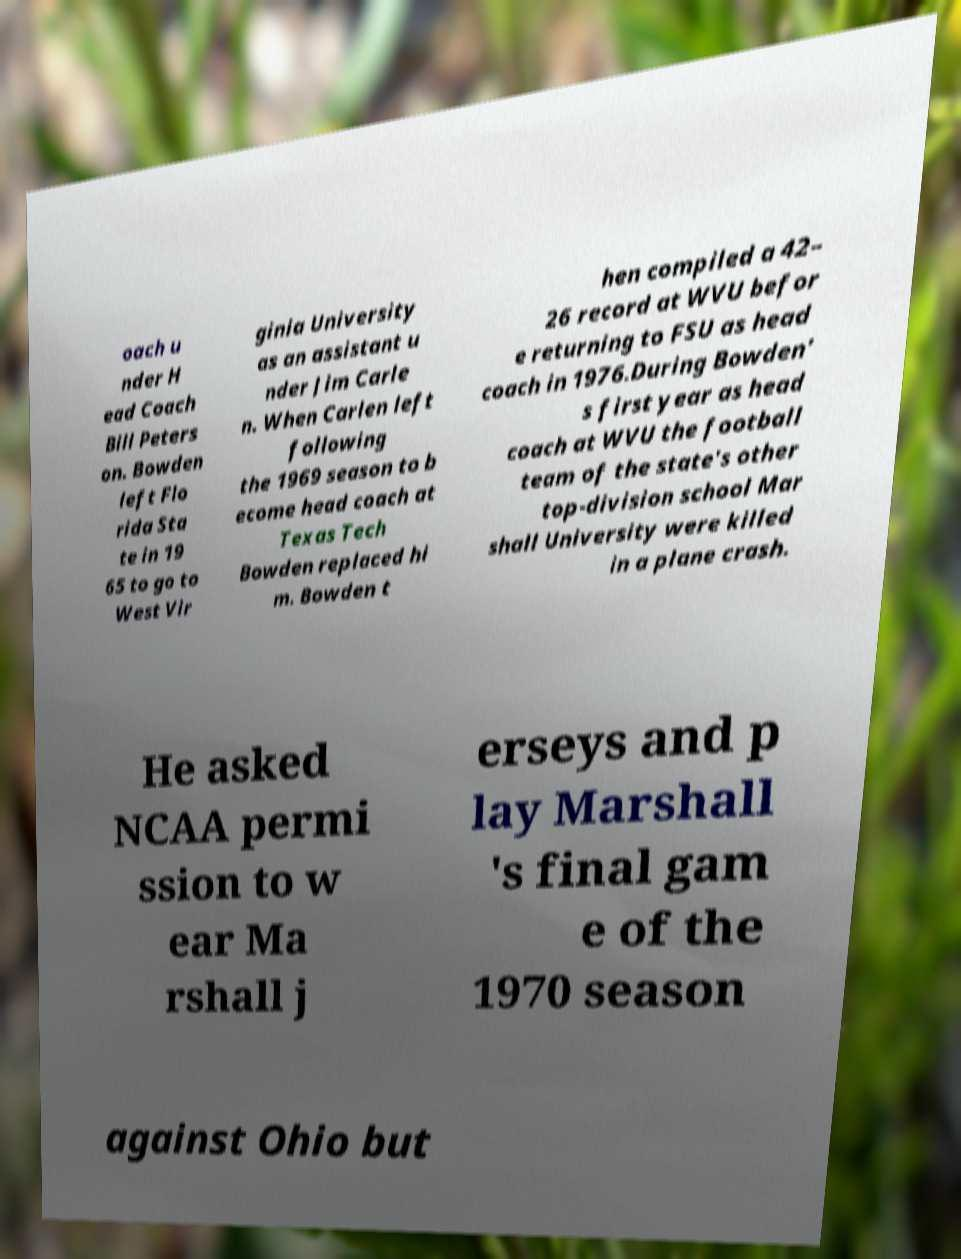Could you extract and type out the text from this image? oach u nder H ead Coach Bill Peters on. Bowden left Flo rida Sta te in 19 65 to go to West Vir ginia University as an assistant u nder Jim Carle n. When Carlen left following the 1969 season to b ecome head coach at Texas Tech Bowden replaced hi m. Bowden t hen compiled a 42– 26 record at WVU befor e returning to FSU as head coach in 1976.During Bowden' s first year as head coach at WVU the football team of the state's other top-division school Mar shall University were killed in a plane crash. He asked NCAA permi ssion to w ear Ma rshall j erseys and p lay Marshall 's final gam e of the 1970 season against Ohio but 